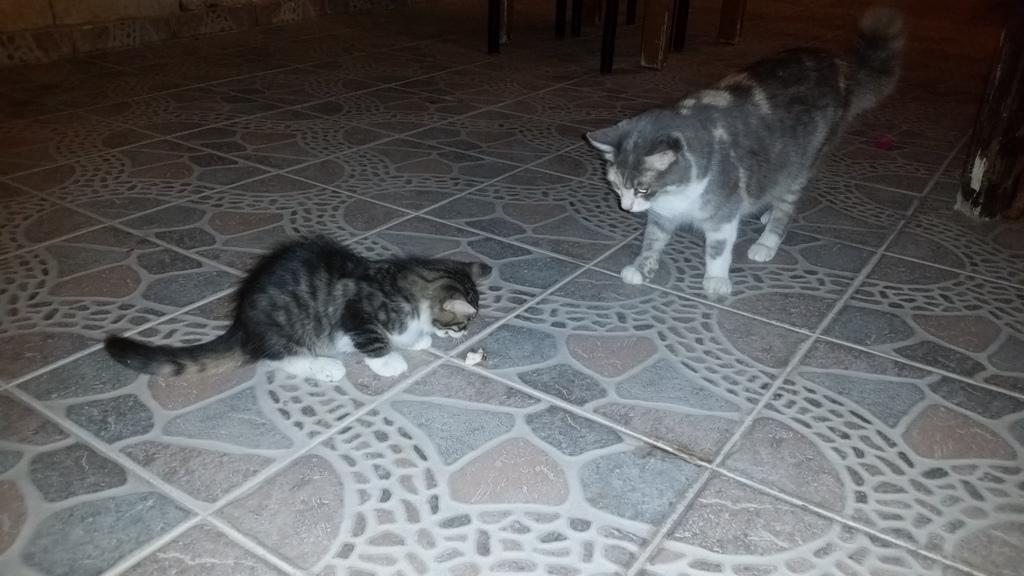What type of animals are in the image? There are cats in the image. What can be seen in the background of the image? There are objects in the background of the image. What part of the image shows the surface on which the cats are standing? The floor is visible at the bottom of the image. What type of instrument is the cat playing in the image? There is no instrument present in the image, and the cats are not playing any instruments. 